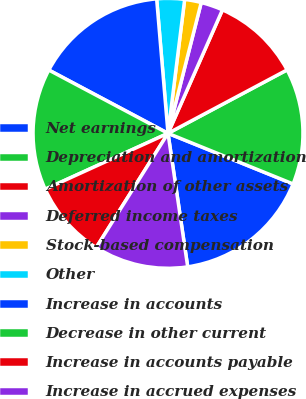Convert chart. <chart><loc_0><loc_0><loc_500><loc_500><pie_chart><fcel>Net earnings<fcel>Depreciation and amortization<fcel>Amortization of other assets<fcel>Deferred income taxes<fcel>Stock-based compensation<fcel>Other<fcel>Increase in accounts<fcel>Decrease in other current<fcel>Increase in accounts payable<fcel>Increase in accrued expenses<nl><fcel>16.55%<fcel>13.91%<fcel>10.6%<fcel>2.65%<fcel>1.99%<fcel>3.31%<fcel>15.89%<fcel>14.57%<fcel>9.27%<fcel>11.26%<nl></chart> 